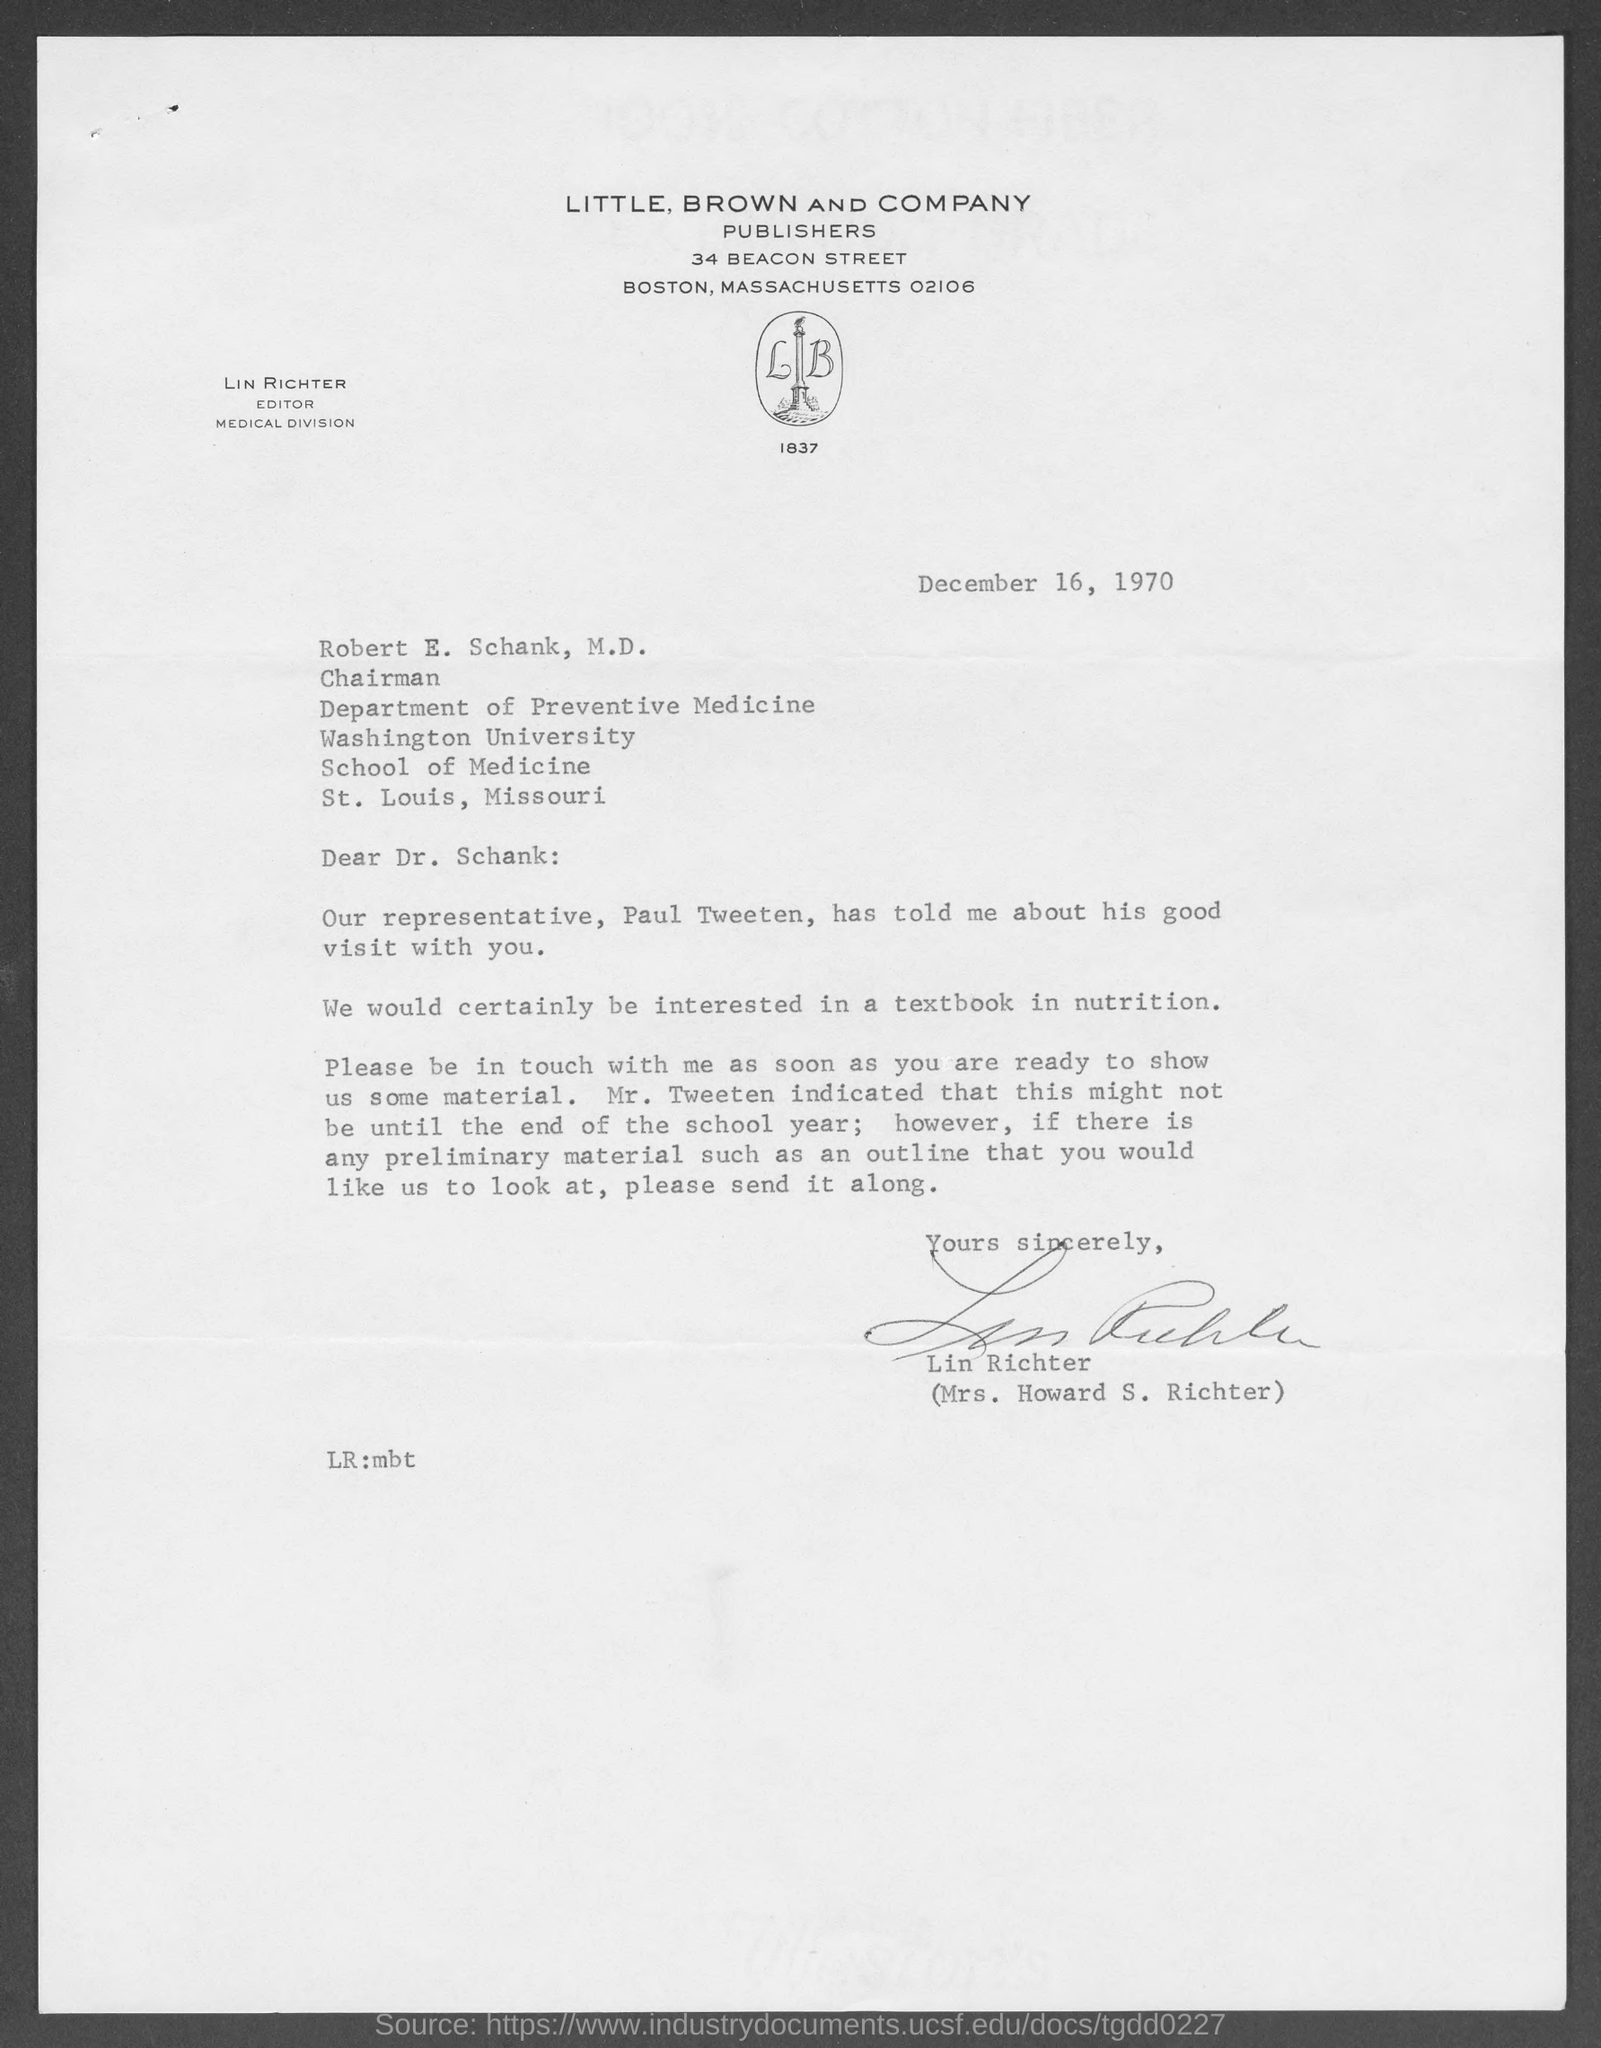Highlight a few significant elements in this photo. Little, Brown and Company are the publishers mentioned in this text. The editor of the Medical Division is Lin Richter. The document is dated December 16, 1970. 